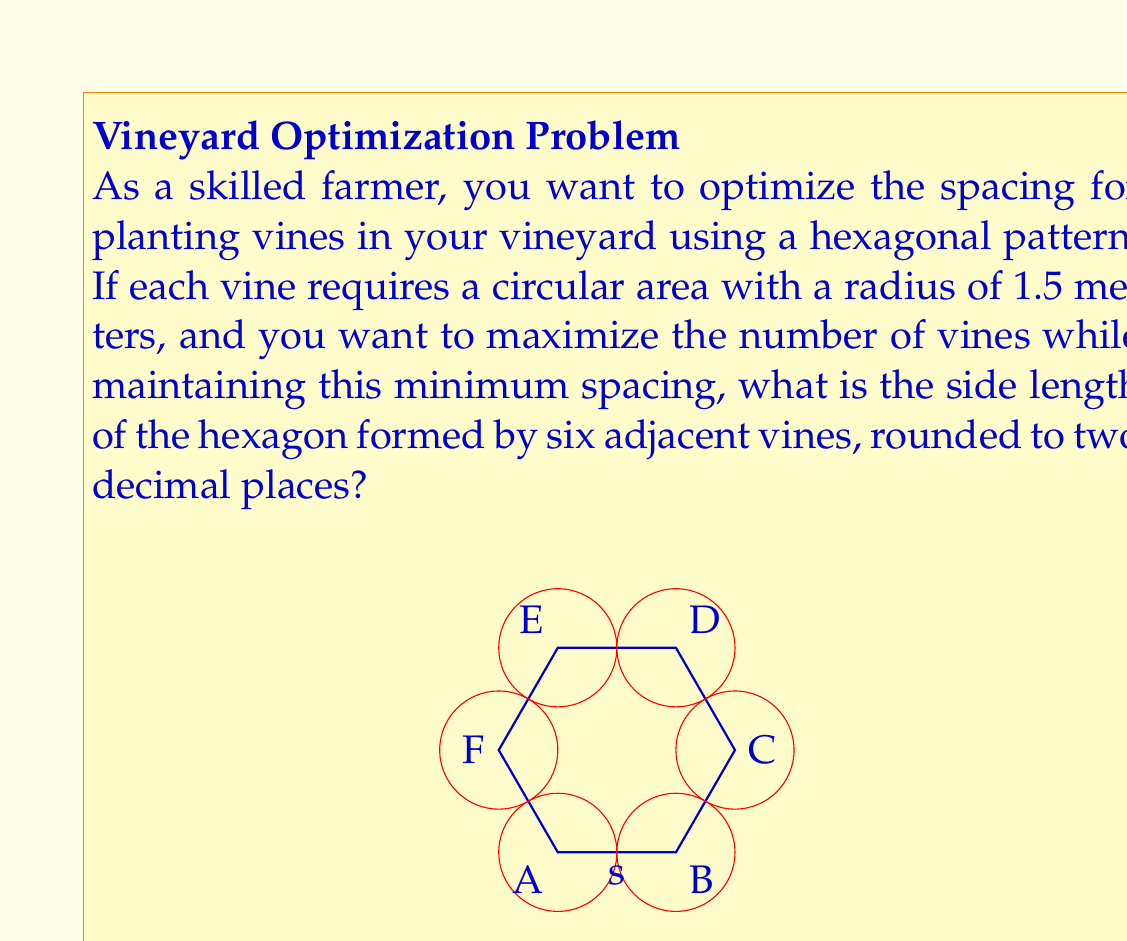Teach me how to tackle this problem. To solve this problem, let's follow these steps:

1) In a hexagonal pattern, the centers of adjacent vines form equilateral triangles. The side length of these triangles is the distance between vine centers, which we'll call $s$.

2) The minimum distance between vine centers is twice the radius of the circular area each vine requires:

   $s = 2 \cdot 1.5 = 3$ meters

3) Now, we need to find the side length of the hexagon. In an equilateral triangle, the relationship between the side length $s$ and the height $h$ is:

   $$h = \frac{\sqrt{3}}{2}s$$

4) The side length of the hexagon is equal to the height of the equilateral triangle. Therefore:

   $$\text{Hexagon side length} = h = \frac{\sqrt{3}}{2}s$$

5) Substituting our value for $s$:

   $$\text{Hexagon side length} = \frac{\sqrt{3}}{2} \cdot 3 = \frac{3\sqrt{3}}{2}$$

6) Calculating this value:

   $$\frac{3\sqrt{3}}{2} \approx 2.5980762113533160$$

7) Rounding to two decimal places:

   $$\text{Hexagon side length} \approx 2.60 \text{ meters}$$

This hexagonal arrangement allows for optimal spacing between vines while maximizing the number of vines that can be planted in a given area.
Answer: The side length of the hexagon formed by six adjacent vines is approximately $2.60$ meters. 